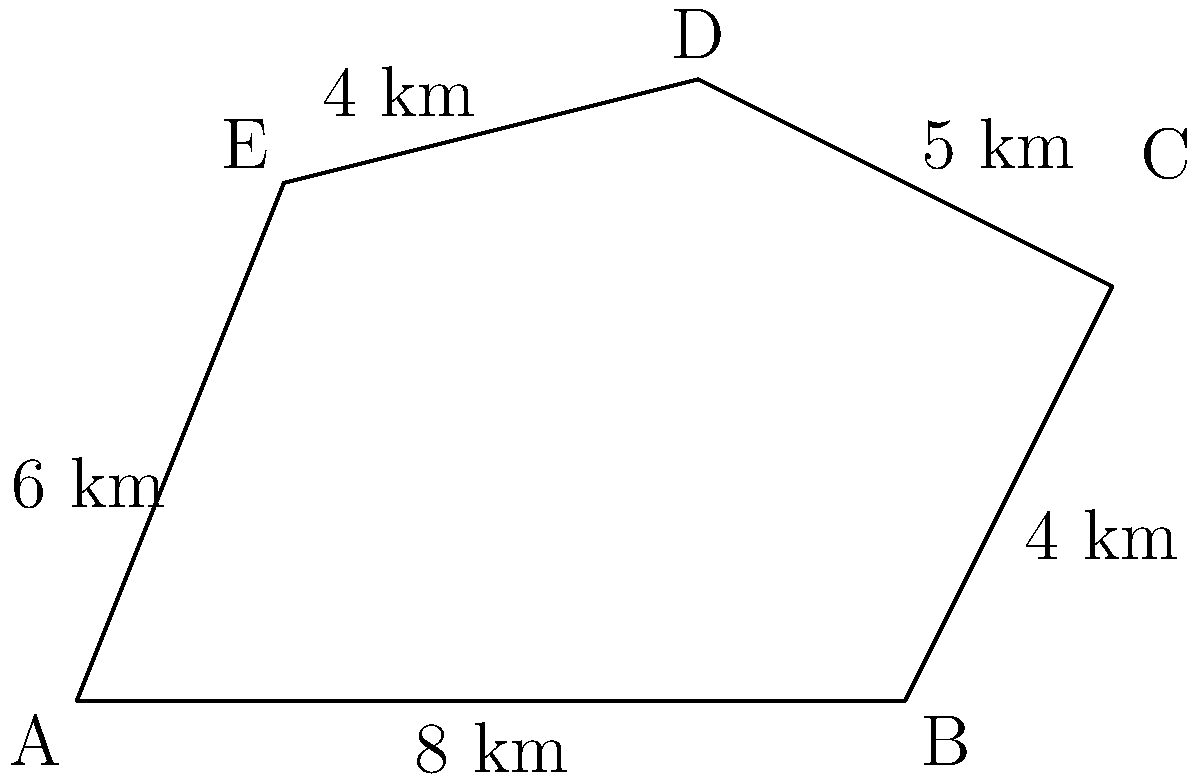A new coastal patrol zone has been established with an irregular pentagon shape as shown in the diagram. The lengths of the sides are given in kilometers. Calculate the area of this patrol zone to determine the coverage of the new coast guard technologies being implemented. To calculate the area of this irregular pentagon, we can use the following steps:

1. Divide the pentagon into three triangles: ABC, ACD, and ADE.

2. Calculate the area of each triangle using Heron's formula:
   $A = \sqrt{s(s-a)(s-b)(s-c)}$
   where $s = \frac{a+b+c}{2}$ (semi-perimeter) and $a$, $b$, $c$ are the side lengths.

3. For triangle ABC:
   $a = 8$, $b = 4$, $c = \sqrt{2^2 + 4^2} = \sqrt{20} \approx 4.47$
   $s = \frac{8 + 4 + 4.47}{2} \approx 8.235$
   $A_{ABC} = \sqrt{8.235(8.235-8)(8.235-4)(8.235-4.47)} \approx 15.96$ km²

4. For triangle ACD:
   $a = 10$, $b = 5$, $c = 6$
   $s = \frac{10 + 5 + 6}{2} = 10.5$
   $A_{ACD} = \sqrt{10.5(10.5-10)(10.5-5)(10.5-6)} \approx 24.74$ km²

5. For triangle ADE:
   $a = 4$, $b = 6$, $c = 2$
   $s = \frac{4 + 6 + 2}{2} = 6$
   $A_{ADE} = \sqrt{6(6-4)(6-6)(6-2)} = 0$ km²

6. Sum the areas of the three triangles:
   $A_{total} = A_{ABC} + A_{ACD} + A_{ADE} \approx 15.96 + 24.74 + 0 = 40.7$ km²

Therefore, the total area of the coastal patrol zone is approximately 40.7 square kilometers.
Answer: 40.7 km² 